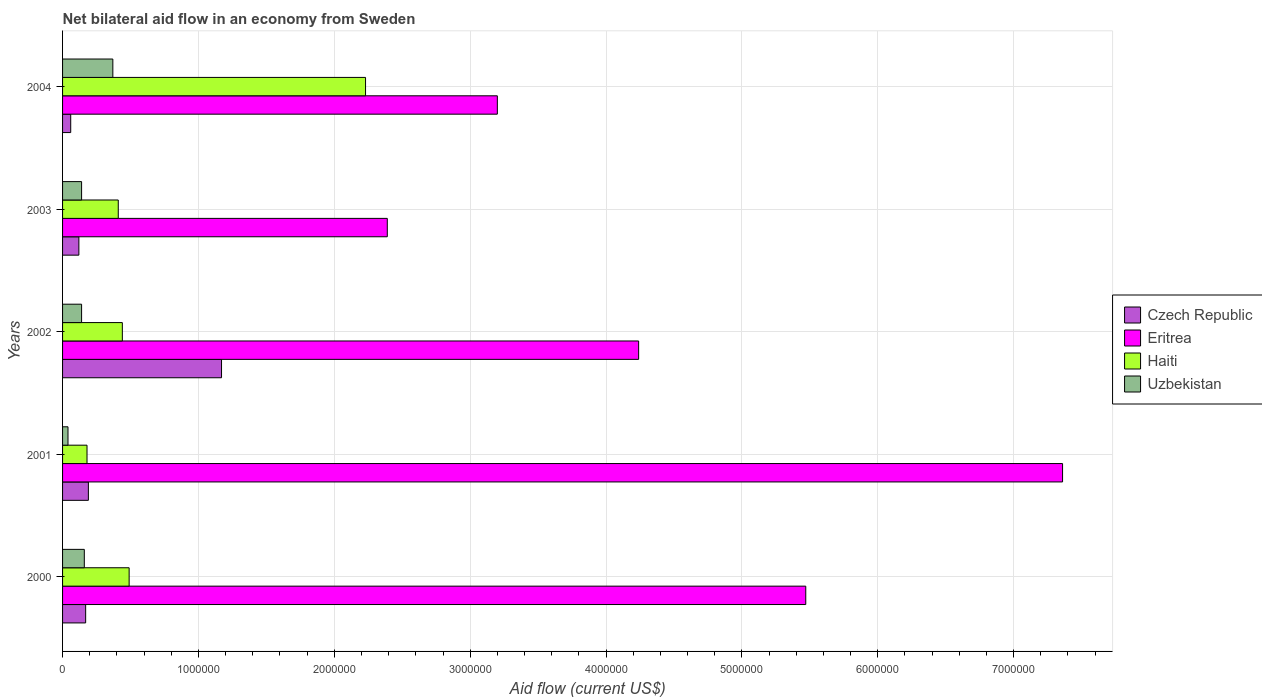Are the number of bars per tick equal to the number of legend labels?
Offer a very short reply. Yes. How many bars are there on the 2nd tick from the bottom?
Your response must be concise. 4. What is the label of the 3rd group of bars from the top?
Give a very brief answer. 2002. In how many cases, is the number of bars for a given year not equal to the number of legend labels?
Provide a succinct answer. 0. What is the net bilateral aid flow in Czech Republic in 2000?
Provide a succinct answer. 1.70e+05. Across all years, what is the maximum net bilateral aid flow in Haiti?
Provide a succinct answer. 2.23e+06. Across all years, what is the minimum net bilateral aid flow in Czech Republic?
Ensure brevity in your answer.  6.00e+04. In which year was the net bilateral aid flow in Haiti maximum?
Offer a terse response. 2004. In which year was the net bilateral aid flow in Czech Republic minimum?
Provide a short and direct response. 2004. What is the total net bilateral aid flow in Uzbekistan in the graph?
Offer a terse response. 8.50e+05. What is the difference between the net bilateral aid flow in Eritrea in 2002 and that in 2004?
Offer a very short reply. 1.04e+06. What is the difference between the net bilateral aid flow in Haiti in 2000 and the net bilateral aid flow in Czech Republic in 2002?
Give a very brief answer. -6.80e+05. What is the average net bilateral aid flow in Eritrea per year?
Your response must be concise. 4.53e+06. In the year 2003, what is the difference between the net bilateral aid flow in Haiti and net bilateral aid flow in Czech Republic?
Your response must be concise. 2.90e+05. In how many years, is the net bilateral aid flow in Eritrea greater than 1600000 US$?
Provide a short and direct response. 5. What is the ratio of the net bilateral aid flow in Czech Republic in 2001 to that in 2002?
Provide a short and direct response. 0.16. What is the difference between the highest and the second highest net bilateral aid flow in Eritrea?
Offer a terse response. 1.89e+06. What is the difference between the highest and the lowest net bilateral aid flow in Haiti?
Keep it short and to the point. 2.05e+06. Is the sum of the net bilateral aid flow in Uzbekistan in 2000 and 2002 greater than the maximum net bilateral aid flow in Haiti across all years?
Keep it short and to the point. No. Is it the case that in every year, the sum of the net bilateral aid flow in Czech Republic and net bilateral aid flow in Eritrea is greater than the sum of net bilateral aid flow in Uzbekistan and net bilateral aid flow in Haiti?
Your answer should be very brief. Yes. What does the 4th bar from the top in 2001 represents?
Provide a short and direct response. Czech Republic. What does the 2nd bar from the bottom in 2000 represents?
Provide a short and direct response. Eritrea. Is it the case that in every year, the sum of the net bilateral aid flow in Uzbekistan and net bilateral aid flow in Eritrea is greater than the net bilateral aid flow in Haiti?
Your response must be concise. Yes. How many years are there in the graph?
Offer a very short reply. 5. What is the difference between two consecutive major ticks on the X-axis?
Your answer should be very brief. 1.00e+06. Are the values on the major ticks of X-axis written in scientific E-notation?
Your answer should be compact. No. Does the graph contain any zero values?
Give a very brief answer. No. Does the graph contain grids?
Your response must be concise. Yes. Where does the legend appear in the graph?
Keep it short and to the point. Center right. How many legend labels are there?
Keep it short and to the point. 4. How are the legend labels stacked?
Provide a succinct answer. Vertical. What is the title of the graph?
Make the answer very short. Net bilateral aid flow in an economy from Sweden. Does "New Zealand" appear as one of the legend labels in the graph?
Your answer should be compact. No. What is the Aid flow (current US$) of Eritrea in 2000?
Provide a short and direct response. 5.47e+06. What is the Aid flow (current US$) of Haiti in 2000?
Give a very brief answer. 4.90e+05. What is the Aid flow (current US$) in Czech Republic in 2001?
Your answer should be very brief. 1.90e+05. What is the Aid flow (current US$) of Eritrea in 2001?
Make the answer very short. 7.36e+06. What is the Aid flow (current US$) in Uzbekistan in 2001?
Offer a very short reply. 4.00e+04. What is the Aid flow (current US$) in Czech Republic in 2002?
Your answer should be compact. 1.17e+06. What is the Aid flow (current US$) in Eritrea in 2002?
Offer a terse response. 4.24e+06. What is the Aid flow (current US$) of Haiti in 2002?
Offer a very short reply. 4.40e+05. What is the Aid flow (current US$) in Czech Republic in 2003?
Make the answer very short. 1.20e+05. What is the Aid flow (current US$) of Eritrea in 2003?
Keep it short and to the point. 2.39e+06. What is the Aid flow (current US$) in Haiti in 2003?
Provide a succinct answer. 4.10e+05. What is the Aid flow (current US$) in Uzbekistan in 2003?
Your answer should be very brief. 1.40e+05. What is the Aid flow (current US$) of Czech Republic in 2004?
Your answer should be compact. 6.00e+04. What is the Aid flow (current US$) of Eritrea in 2004?
Provide a succinct answer. 3.20e+06. What is the Aid flow (current US$) in Haiti in 2004?
Give a very brief answer. 2.23e+06. What is the Aid flow (current US$) of Uzbekistan in 2004?
Your response must be concise. 3.70e+05. Across all years, what is the maximum Aid flow (current US$) of Czech Republic?
Offer a very short reply. 1.17e+06. Across all years, what is the maximum Aid flow (current US$) of Eritrea?
Your answer should be compact. 7.36e+06. Across all years, what is the maximum Aid flow (current US$) of Haiti?
Keep it short and to the point. 2.23e+06. Across all years, what is the maximum Aid flow (current US$) in Uzbekistan?
Make the answer very short. 3.70e+05. Across all years, what is the minimum Aid flow (current US$) in Eritrea?
Provide a succinct answer. 2.39e+06. Across all years, what is the minimum Aid flow (current US$) in Haiti?
Offer a very short reply. 1.80e+05. What is the total Aid flow (current US$) in Czech Republic in the graph?
Your answer should be compact. 1.71e+06. What is the total Aid flow (current US$) of Eritrea in the graph?
Your answer should be very brief. 2.27e+07. What is the total Aid flow (current US$) of Haiti in the graph?
Offer a terse response. 3.75e+06. What is the total Aid flow (current US$) in Uzbekistan in the graph?
Offer a terse response. 8.50e+05. What is the difference between the Aid flow (current US$) of Eritrea in 2000 and that in 2001?
Ensure brevity in your answer.  -1.89e+06. What is the difference between the Aid flow (current US$) in Haiti in 2000 and that in 2001?
Your answer should be compact. 3.10e+05. What is the difference between the Aid flow (current US$) of Uzbekistan in 2000 and that in 2001?
Your answer should be compact. 1.20e+05. What is the difference between the Aid flow (current US$) of Czech Republic in 2000 and that in 2002?
Your response must be concise. -1.00e+06. What is the difference between the Aid flow (current US$) of Eritrea in 2000 and that in 2002?
Provide a short and direct response. 1.23e+06. What is the difference between the Aid flow (current US$) of Haiti in 2000 and that in 2002?
Offer a terse response. 5.00e+04. What is the difference between the Aid flow (current US$) in Uzbekistan in 2000 and that in 2002?
Make the answer very short. 2.00e+04. What is the difference between the Aid flow (current US$) of Eritrea in 2000 and that in 2003?
Provide a succinct answer. 3.08e+06. What is the difference between the Aid flow (current US$) in Eritrea in 2000 and that in 2004?
Your answer should be compact. 2.27e+06. What is the difference between the Aid flow (current US$) of Haiti in 2000 and that in 2004?
Offer a terse response. -1.74e+06. What is the difference between the Aid flow (current US$) of Czech Republic in 2001 and that in 2002?
Keep it short and to the point. -9.80e+05. What is the difference between the Aid flow (current US$) in Eritrea in 2001 and that in 2002?
Provide a succinct answer. 3.12e+06. What is the difference between the Aid flow (current US$) in Eritrea in 2001 and that in 2003?
Your answer should be compact. 4.97e+06. What is the difference between the Aid flow (current US$) in Haiti in 2001 and that in 2003?
Provide a succinct answer. -2.30e+05. What is the difference between the Aid flow (current US$) of Uzbekistan in 2001 and that in 2003?
Your answer should be compact. -1.00e+05. What is the difference between the Aid flow (current US$) of Czech Republic in 2001 and that in 2004?
Offer a terse response. 1.30e+05. What is the difference between the Aid flow (current US$) of Eritrea in 2001 and that in 2004?
Provide a succinct answer. 4.16e+06. What is the difference between the Aid flow (current US$) of Haiti in 2001 and that in 2004?
Offer a very short reply. -2.05e+06. What is the difference between the Aid flow (current US$) in Uzbekistan in 2001 and that in 2004?
Make the answer very short. -3.30e+05. What is the difference between the Aid flow (current US$) of Czech Republic in 2002 and that in 2003?
Your response must be concise. 1.05e+06. What is the difference between the Aid flow (current US$) of Eritrea in 2002 and that in 2003?
Make the answer very short. 1.85e+06. What is the difference between the Aid flow (current US$) of Czech Republic in 2002 and that in 2004?
Your response must be concise. 1.11e+06. What is the difference between the Aid flow (current US$) of Eritrea in 2002 and that in 2004?
Offer a very short reply. 1.04e+06. What is the difference between the Aid flow (current US$) of Haiti in 2002 and that in 2004?
Provide a short and direct response. -1.79e+06. What is the difference between the Aid flow (current US$) in Uzbekistan in 2002 and that in 2004?
Offer a terse response. -2.30e+05. What is the difference between the Aid flow (current US$) in Czech Republic in 2003 and that in 2004?
Offer a very short reply. 6.00e+04. What is the difference between the Aid flow (current US$) in Eritrea in 2003 and that in 2004?
Offer a terse response. -8.10e+05. What is the difference between the Aid flow (current US$) of Haiti in 2003 and that in 2004?
Offer a very short reply. -1.82e+06. What is the difference between the Aid flow (current US$) in Czech Republic in 2000 and the Aid flow (current US$) in Eritrea in 2001?
Offer a terse response. -7.19e+06. What is the difference between the Aid flow (current US$) of Eritrea in 2000 and the Aid flow (current US$) of Haiti in 2001?
Ensure brevity in your answer.  5.29e+06. What is the difference between the Aid flow (current US$) in Eritrea in 2000 and the Aid flow (current US$) in Uzbekistan in 2001?
Offer a very short reply. 5.43e+06. What is the difference between the Aid flow (current US$) in Czech Republic in 2000 and the Aid flow (current US$) in Eritrea in 2002?
Offer a terse response. -4.07e+06. What is the difference between the Aid flow (current US$) in Czech Republic in 2000 and the Aid flow (current US$) in Uzbekistan in 2002?
Give a very brief answer. 3.00e+04. What is the difference between the Aid flow (current US$) of Eritrea in 2000 and the Aid flow (current US$) of Haiti in 2002?
Keep it short and to the point. 5.03e+06. What is the difference between the Aid flow (current US$) of Eritrea in 2000 and the Aid flow (current US$) of Uzbekistan in 2002?
Ensure brevity in your answer.  5.33e+06. What is the difference between the Aid flow (current US$) in Czech Republic in 2000 and the Aid flow (current US$) in Eritrea in 2003?
Ensure brevity in your answer.  -2.22e+06. What is the difference between the Aid flow (current US$) of Czech Republic in 2000 and the Aid flow (current US$) of Uzbekistan in 2003?
Your response must be concise. 3.00e+04. What is the difference between the Aid flow (current US$) in Eritrea in 2000 and the Aid flow (current US$) in Haiti in 2003?
Your answer should be compact. 5.06e+06. What is the difference between the Aid flow (current US$) of Eritrea in 2000 and the Aid flow (current US$) of Uzbekistan in 2003?
Ensure brevity in your answer.  5.33e+06. What is the difference between the Aid flow (current US$) of Czech Republic in 2000 and the Aid flow (current US$) of Eritrea in 2004?
Offer a terse response. -3.03e+06. What is the difference between the Aid flow (current US$) in Czech Republic in 2000 and the Aid flow (current US$) in Haiti in 2004?
Your answer should be very brief. -2.06e+06. What is the difference between the Aid flow (current US$) of Eritrea in 2000 and the Aid flow (current US$) of Haiti in 2004?
Offer a very short reply. 3.24e+06. What is the difference between the Aid flow (current US$) in Eritrea in 2000 and the Aid flow (current US$) in Uzbekistan in 2004?
Provide a short and direct response. 5.10e+06. What is the difference between the Aid flow (current US$) of Haiti in 2000 and the Aid flow (current US$) of Uzbekistan in 2004?
Your answer should be compact. 1.20e+05. What is the difference between the Aid flow (current US$) in Czech Republic in 2001 and the Aid flow (current US$) in Eritrea in 2002?
Keep it short and to the point. -4.05e+06. What is the difference between the Aid flow (current US$) in Czech Republic in 2001 and the Aid flow (current US$) in Haiti in 2002?
Your answer should be very brief. -2.50e+05. What is the difference between the Aid flow (current US$) of Czech Republic in 2001 and the Aid flow (current US$) of Uzbekistan in 2002?
Give a very brief answer. 5.00e+04. What is the difference between the Aid flow (current US$) in Eritrea in 2001 and the Aid flow (current US$) in Haiti in 2002?
Your response must be concise. 6.92e+06. What is the difference between the Aid flow (current US$) of Eritrea in 2001 and the Aid flow (current US$) of Uzbekistan in 2002?
Make the answer very short. 7.22e+06. What is the difference between the Aid flow (current US$) of Czech Republic in 2001 and the Aid flow (current US$) of Eritrea in 2003?
Keep it short and to the point. -2.20e+06. What is the difference between the Aid flow (current US$) in Czech Republic in 2001 and the Aid flow (current US$) in Haiti in 2003?
Your response must be concise. -2.20e+05. What is the difference between the Aid flow (current US$) in Eritrea in 2001 and the Aid flow (current US$) in Haiti in 2003?
Offer a very short reply. 6.95e+06. What is the difference between the Aid flow (current US$) in Eritrea in 2001 and the Aid flow (current US$) in Uzbekistan in 2003?
Give a very brief answer. 7.22e+06. What is the difference between the Aid flow (current US$) of Czech Republic in 2001 and the Aid flow (current US$) of Eritrea in 2004?
Your response must be concise. -3.01e+06. What is the difference between the Aid flow (current US$) of Czech Republic in 2001 and the Aid flow (current US$) of Haiti in 2004?
Provide a short and direct response. -2.04e+06. What is the difference between the Aid flow (current US$) of Czech Republic in 2001 and the Aid flow (current US$) of Uzbekistan in 2004?
Make the answer very short. -1.80e+05. What is the difference between the Aid flow (current US$) in Eritrea in 2001 and the Aid flow (current US$) in Haiti in 2004?
Your answer should be compact. 5.13e+06. What is the difference between the Aid flow (current US$) in Eritrea in 2001 and the Aid flow (current US$) in Uzbekistan in 2004?
Your answer should be compact. 6.99e+06. What is the difference between the Aid flow (current US$) of Czech Republic in 2002 and the Aid flow (current US$) of Eritrea in 2003?
Make the answer very short. -1.22e+06. What is the difference between the Aid flow (current US$) of Czech Republic in 2002 and the Aid flow (current US$) of Haiti in 2003?
Provide a succinct answer. 7.60e+05. What is the difference between the Aid flow (current US$) in Czech Republic in 2002 and the Aid flow (current US$) in Uzbekistan in 2003?
Your answer should be compact. 1.03e+06. What is the difference between the Aid flow (current US$) in Eritrea in 2002 and the Aid flow (current US$) in Haiti in 2003?
Make the answer very short. 3.83e+06. What is the difference between the Aid flow (current US$) of Eritrea in 2002 and the Aid flow (current US$) of Uzbekistan in 2003?
Offer a very short reply. 4.10e+06. What is the difference between the Aid flow (current US$) of Czech Republic in 2002 and the Aid flow (current US$) of Eritrea in 2004?
Your response must be concise. -2.03e+06. What is the difference between the Aid flow (current US$) of Czech Republic in 2002 and the Aid flow (current US$) of Haiti in 2004?
Provide a succinct answer. -1.06e+06. What is the difference between the Aid flow (current US$) in Czech Republic in 2002 and the Aid flow (current US$) in Uzbekistan in 2004?
Provide a short and direct response. 8.00e+05. What is the difference between the Aid flow (current US$) of Eritrea in 2002 and the Aid flow (current US$) of Haiti in 2004?
Make the answer very short. 2.01e+06. What is the difference between the Aid flow (current US$) of Eritrea in 2002 and the Aid flow (current US$) of Uzbekistan in 2004?
Provide a short and direct response. 3.87e+06. What is the difference between the Aid flow (current US$) in Czech Republic in 2003 and the Aid flow (current US$) in Eritrea in 2004?
Keep it short and to the point. -3.08e+06. What is the difference between the Aid flow (current US$) of Czech Republic in 2003 and the Aid flow (current US$) of Haiti in 2004?
Make the answer very short. -2.11e+06. What is the difference between the Aid flow (current US$) in Czech Republic in 2003 and the Aid flow (current US$) in Uzbekistan in 2004?
Offer a very short reply. -2.50e+05. What is the difference between the Aid flow (current US$) in Eritrea in 2003 and the Aid flow (current US$) in Uzbekistan in 2004?
Your answer should be compact. 2.02e+06. What is the average Aid flow (current US$) of Czech Republic per year?
Make the answer very short. 3.42e+05. What is the average Aid flow (current US$) of Eritrea per year?
Your answer should be compact. 4.53e+06. What is the average Aid flow (current US$) of Haiti per year?
Offer a terse response. 7.50e+05. In the year 2000, what is the difference between the Aid flow (current US$) of Czech Republic and Aid flow (current US$) of Eritrea?
Your response must be concise. -5.30e+06. In the year 2000, what is the difference between the Aid flow (current US$) in Czech Republic and Aid flow (current US$) in Haiti?
Make the answer very short. -3.20e+05. In the year 2000, what is the difference between the Aid flow (current US$) in Czech Republic and Aid flow (current US$) in Uzbekistan?
Ensure brevity in your answer.  10000. In the year 2000, what is the difference between the Aid flow (current US$) of Eritrea and Aid flow (current US$) of Haiti?
Offer a very short reply. 4.98e+06. In the year 2000, what is the difference between the Aid flow (current US$) of Eritrea and Aid flow (current US$) of Uzbekistan?
Keep it short and to the point. 5.31e+06. In the year 2001, what is the difference between the Aid flow (current US$) of Czech Republic and Aid flow (current US$) of Eritrea?
Your answer should be compact. -7.17e+06. In the year 2001, what is the difference between the Aid flow (current US$) of Czech Republic and Aid flow (current US$) of Haiti?
Keep it short and to the point. 10000. In the year 2001, what is the difference between the Aid flow (current US$) in Czech Republic and Aid flow (current US$) in Uzbekistan?
Make the answer very short. 1.50e+05. In the year 2001, what is the difference between the Aid flow (current US$) of Eritrea and Aid flow (current US$) of Haiti?
Offer a terse response. 7.18e+06. In the year 2001, what is the difference between the Aid flow (current US$) of Eritrea and Aid flow (current US$) of Uzbekistan?
Give a very brief answer. 7.32e+06. In the year 2001, what is the difference between the Aid flow (current US$) of Haiti and Aid flow (current US$) of Uzbekistan?
Your answer should be compact. 1.40e+05. In the year 2002, what is the difference between the Aid flow (current US$) in Czech Republic and Aid flow (current US$) in Eritrea?
Your answer should be very brief. -3.07e+06. In the year 2002, what is the difference between the Aid flow (current US$) of Czech Republic and Aid flow (current US$) of Haiti?
Ensure brevity in your answer.  7.30e+05. In the year 2002, what is the difference between the Aid flow (current US$) in Czech Republic and Aid flow (current US$) in Uzbekistan?
Make the answer very short. 1.03e+06. In the year 2002, what is the difference between the Aid flow (current US$) of Eritrea and Aid flow (current US$) of Haiti?
Your response must be concise. 3.80e+06. In the year 2002, what is the difference between the Aid flow (current US$) in Eritrea and Aid flow (current US$) in Uzbekistan?
Ensure brevity in your answer.  4.10e+06. In the year 2003, what is the difference between the Aid flow (current US$) of Czech Republic and Aid flow (current US$) of Eritrea?
Offer a very short reply. -2.27e+06. In the year 2003, what is the difference between the Aid flow (current US$) of Czech Republic and Aid flow (current US$) of Haiti?
Make the answer very short. -2.90e+05. In the year 2003, what is the difference between the Aid flow (current US$) in Czech Republic and Aid flow (current US$) in Uzbekistan?
Offer a terse response. -2.00e+04. In the year 2003, what is the difference between the Aid flow (current US$) of Eritrea and Aid flow (current US$) of Haiti?
Offer a terse response. 1.98e+06. In the year 2003, what is the difference between the Aid flow (current US$) of Eritrea and Aid flow (current US$) of Uzbekistan?
Keep it short and to the point. 2.25e+06. In the year 2003, what is the difference between the Aid flow (current US$) in Haiti and Aid flow (current US$) in Uzbekistan?
Offer a very short reply. 2.70e+05. In the year 2004, what is the difference between the Aid flow (current US$) of Czech Republic and Aid flow (current US$) of Eritrea?
Offer a terse response. -3.14e+06. In the year 2004, what is the difference between the Aid flow (current US$) of Czech Republic and Aid flow (current US$) of Haiti?
Your answer should be very brief. -2.17e+06. In the year 2004, what is the difference between the Aid flow (current US$) in Czech Republic and Aid flow (current US$) in Uzbekistan?
Keep it short and to the point. -3.10e+05. In the year 2004, what is the difference between the Aid flow (current US$) of Eritrea and Aid flow (current US$) of Haiti?
Offer a terse response. 9.70e+05. In the year 2004, what is the difference between the Aid flow (current US$) in Eritrea and Aid flow (current US$) in Uzbekistan?
Keep it short and to the point. 2.83e+06. In the year 2004, what is the difference between the Aid flow (current US$) of Haiti and Aid flow (current US$) of Uzbekistan?
Ensure brevity in your answer.  1.86e+06. What is the ratio of the Aid flow (current US$) of Czech Republic in 2000 to that in 2001?
Your answer should be compact. 0.89. What is the ratio of the Aid flow (current US$) of Eritrea in 2000 to that in 2001?
Your answer should be very brief. 0.74. What is the ratio of the Aid flow (current US$) in Haiti in 2000 to that in 2001?
Provide a short and direct response. 2.72. What is the ratio of the Aid flow (current US$) of Uzbekistan in 2000 to that in 2001?
Provide a succinct answer. 4. What is the ratio of the Aid flow (current US$) of Czech Republic in 2000 to that in 2002?
Keep it short and to the point. 0.15. What is the ratio of the Aid flow (current US$) of Eritrea in 2000 to that in 2002?
Your answer should be compact. 1.29. What is the ratio of the Aid flow (current US$) in Haiti in 2000 to that in 2002?
Provide a succinct answer. 1.11. What is the ratio of the Aid flow (current US$) in Uzbekistan in 2000 to that in 2002?
Offer a very short reply. 1.14. What is the ratio of the Aid flow (current US$) in Czech Republic in 2000 to that in 2003?
Offer a terse response. 1.42. What is the ratio of the Aid flow (current US$) in Eritrea in 2000 to that in 2003?
Your answer should be compact. 2.29. What is the ratio of the Aid flow (current US$) of Haiti in 2000 to that in 2003?
Give a very brief answer. 1.2. What is the ratio of the Aid flow (current US$) of Uzbekistan in 2000 to that in 2003?
Your answer should be compact. 1.14. What is the ratio of the Aid flow (current US$) of Czech Republic in 2000 to that in 2004?
Your answer should be very brief. 2.83. What is the ratio of the Aid flow (current US$) in Eritrea in 2000 to that in 2004?
Offer a very short reply. 1.71. What is the ratio of the Aid flow (current US$) of Haiti in 2000 to that in 2004?
Provide a succinct answer. 0.22. What is the ratio of the Aid flow (current US$) of Uzbekistan in 2000 to that in 2004?
Provide a short and direct response. 0.43. What is the ratio of the Aid flow (current US$) in Czech Republic in 2001 to that in 2002?
Make the answer very short. 0.16. What is the ratio of the Aid flow (current US$) of Eritrea in 2001 to that in 2002?
Your response must be concise. 1.74. What is the ratio of the Aid flow (current US$) of Haiti in 2001 to that in 2002?
Offer a terse response. 0.41. What is the ratio of the Aid flow (current US$) of Uzbekistan in 2001 to that in 2002?
Keep it short and to the point. 0.29. What is the ratio of the Aid flow (current US$) of Czech Republic in 2001 to that in 2003?
Your answer should be very brief. 1.58. What is the ratio of the Aid flow (current US$) in Eritrea in 2001 to that in 2003?
Ensure brevity in your answer.  3.08. What is the ratio of the Aid flow (current US$) of Haiti in 2001 to that in 2003?
Provide a short and direct response. 0.44. What is the ratio of the Aid flow (current US$) in Uzbekistan in 2001 to that in 2003?
Give a very brief answer. 0.29. What is the ratio of the Aid flow (current US$) in Czech Republic in 2001 to that in 2004?
Offer a terse response. 3.17. What is the ratio of the Aid flow (current US$) in Haiti in 2001 to that in 2004?
Your response must be concise. 0.08. What is the ratio of the Aid flow (current US$) in Uzbekistan in 2001 to that in 2004?
Your response must be concise. 0.11. What is the ratio of the Aid flow (current US$) in Czech Republic in 2002 to that in 2003?
Your answer should be very brief. 9.75. What is the ratio of the Aid flow (current US$) of Eritrea in 2002 to that in 2003?
Your response must be concise. 1.77. What is the ratio of the Aid flow (current US$) of Haiti in 2002 to that in 2003?
Provide a succinct answer. 1.07. What is the ratio of the Aid flow (current US$) in Uzbekistan in 2002 to that in 2003?
Ensure brevity in your answer.  1. What is the ratio of the Aid flow (current US$) in Eritrea in 2002 to that in 2004?
Offer a terse response. 1.32. What is the ratio of the Aid flow (current US$) of Haiti in 2002 to that in 2004?
Make the answer very short. 0.2. What is the ratio of the Aid flow (current US$) in Uzbekistan in 2002 to that in 2004?
Make the answer very short. 0.38. What is the ratio of the Aid flow (current US$) in Czech Republic in 2003 to that in 2004?
Offer a very short reply. 2. What is the ratio of the Aid flow (current US$) of Eritrea in 2003 to that in 2004?
Ensure brevity in your answer.  0.75. What is the ratio of the Aid flow (current US$) in Haiti in 2003 to that in 2004?
Provide a succinct answer. 0.18. What is the ratio of the Aid flow (current US$) of Uzbekistan in 2003 to that in 2004?
Give a very brief answer. 0.38. What is the difference between the highest and the second highest Aid flow (current US$) of Czech Republic?
Offer a very short reply. 9.80e+05. What is the difference between the highest and the second highest Aid flow (current US$) of Eritrea?
Keep it short and to the point. 1.89e+06. What is the difference between the highest and the second highest Aid flow (current US$) of Haiti?
Your answer should be compact. 1.74e+06. What is the difference between the highest and the lowest Aid flow (current US$) in Czech Republic?
Your answer should be very brief. 1.11e+06. What is the difference between the highest and the lowest Aid flow (current US$) in Eritrea?
Your answer should be very brief. 4.97e+06. What is the difference between the highest and the lowest Aid flow (current US$) in Haiti?
Provide a short and direct response. 2.05e+06. 